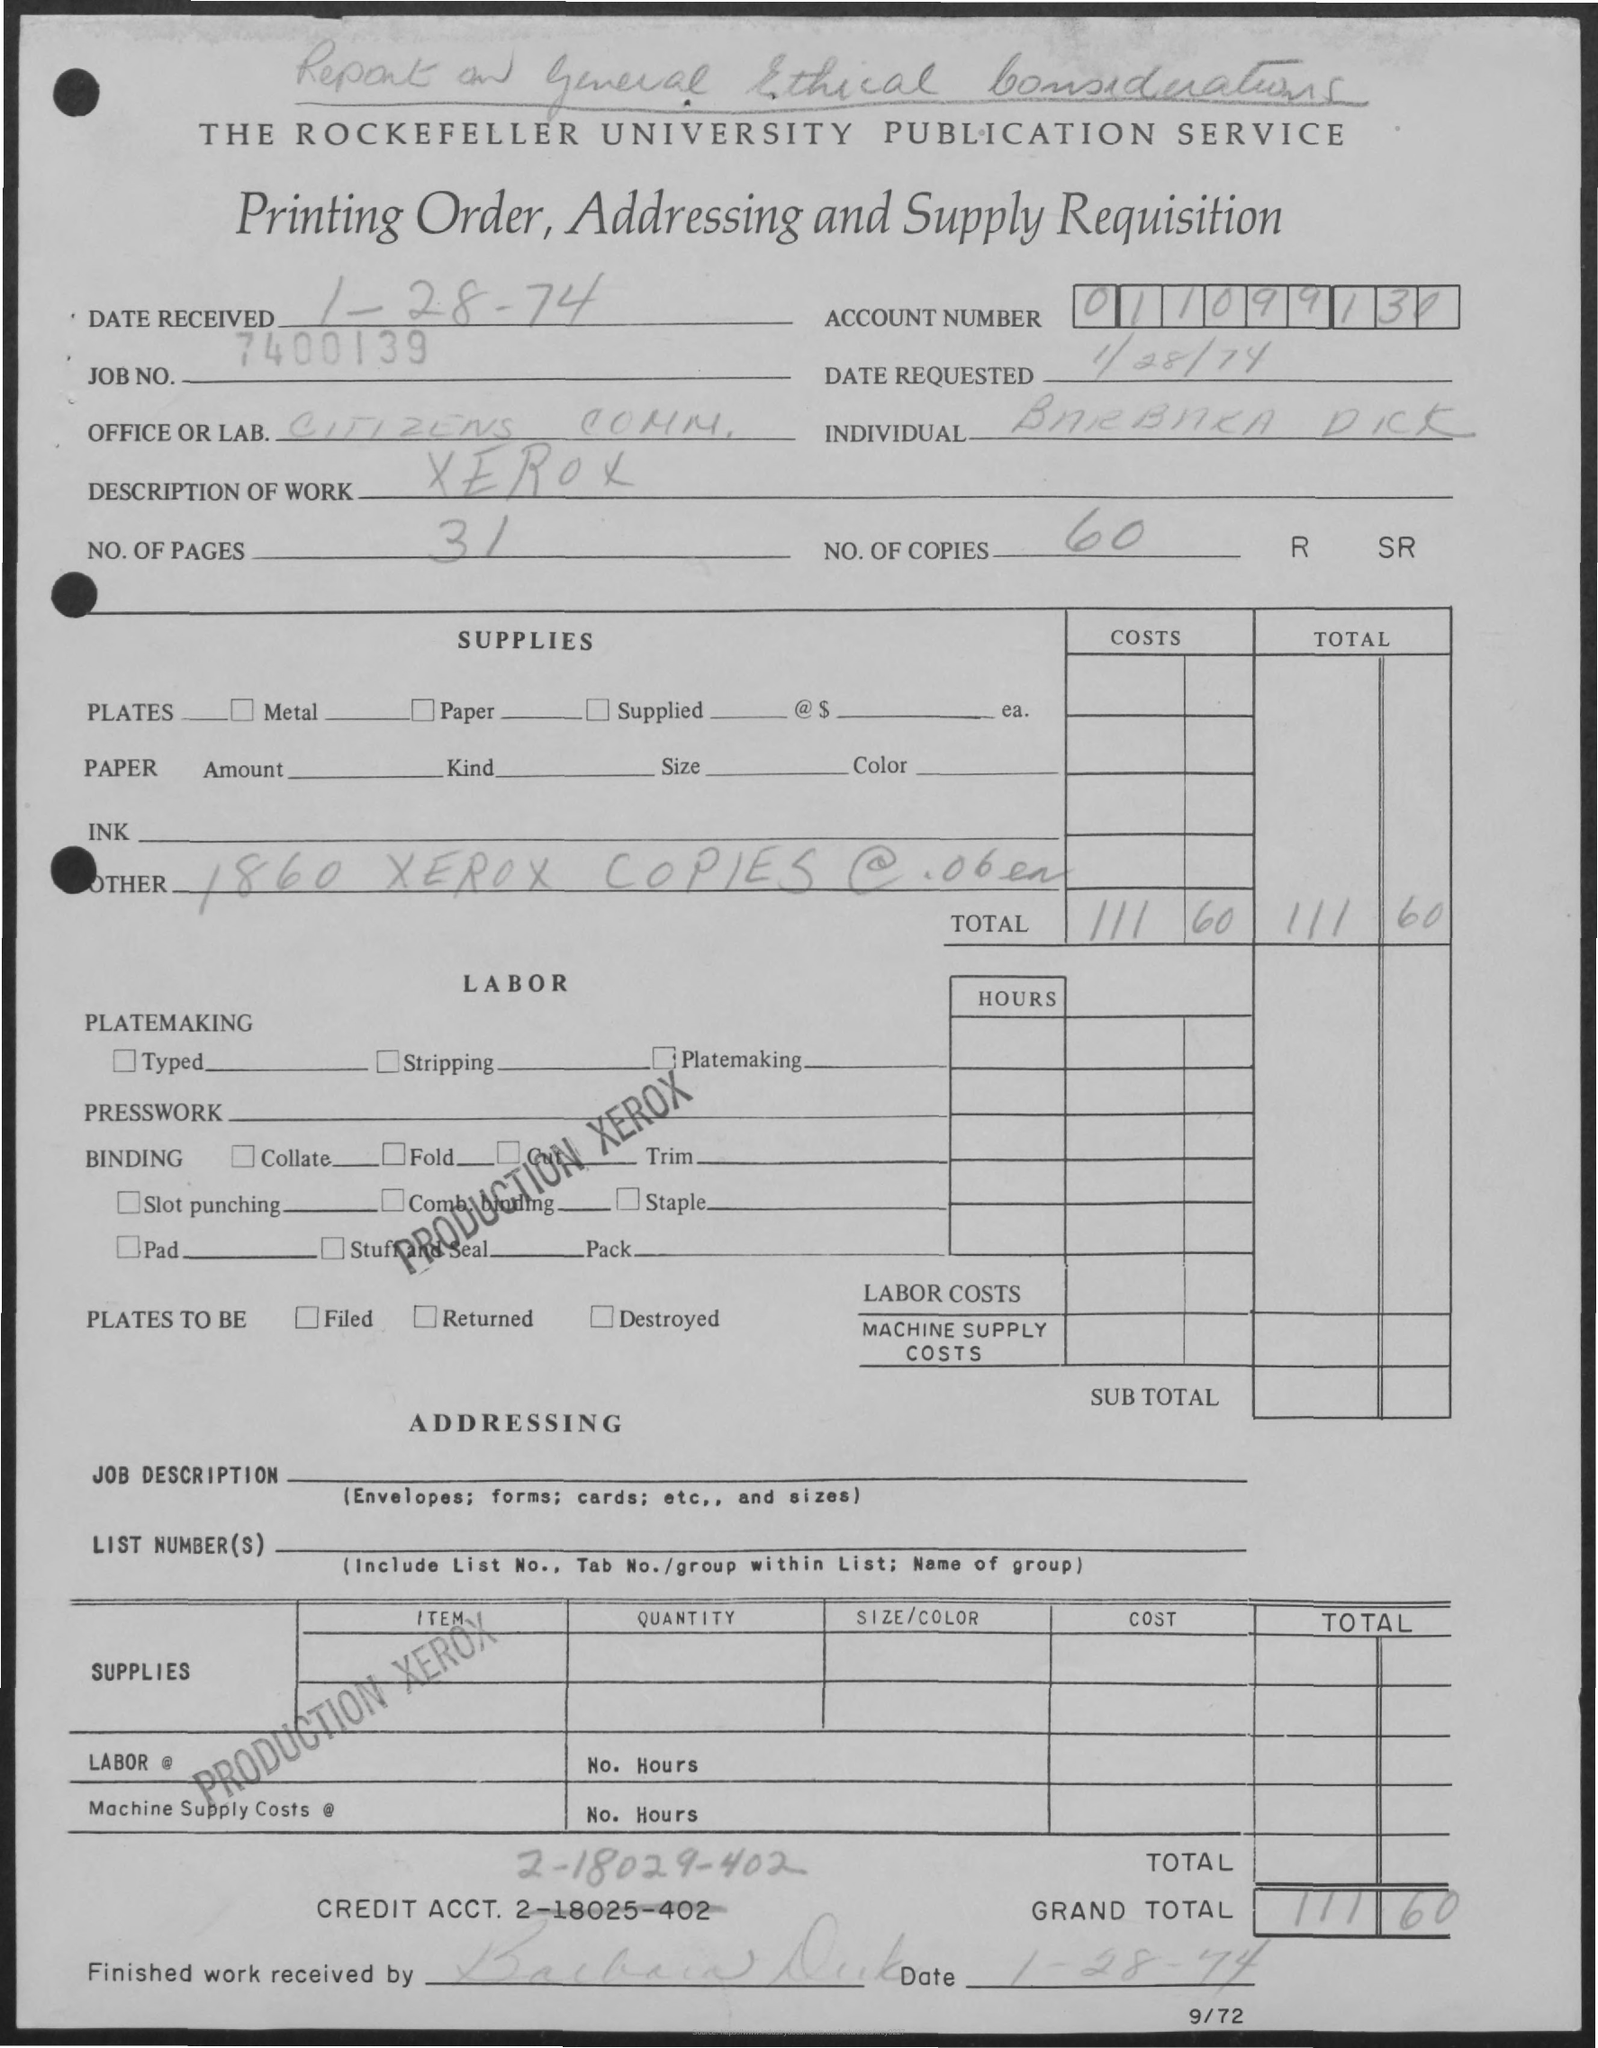List a handful of essential elements in this visual. There are 31 pages in total. The account number is 011099130. The description of work refers to the specific tasks and duties that are required to complete a particular project or task. In the case of Xerox, the description of work may involve the copying and printing of various documents, as well as the maintenance and repair of Xerox equipment. There are 60 copies available. The job number is 7400139.. 